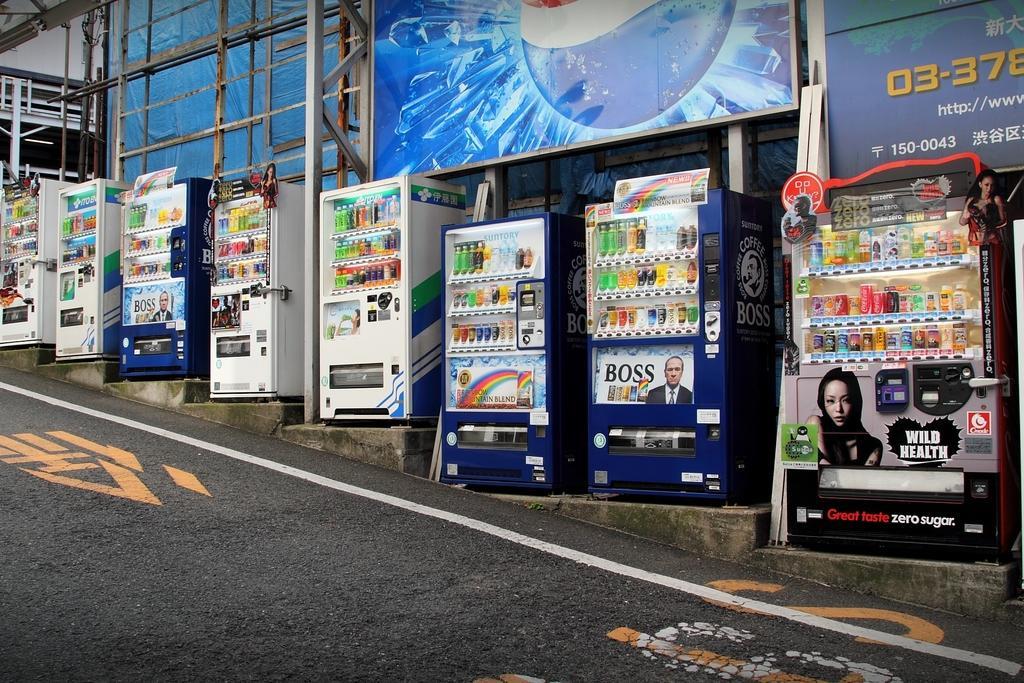Describe this image in one or two sentences. In this image there are few vending machines which are kept on the stairs. Vending machines are having few bottles in it. Behind them there is banner. Bottom of image there is road having few painted lines on it. 